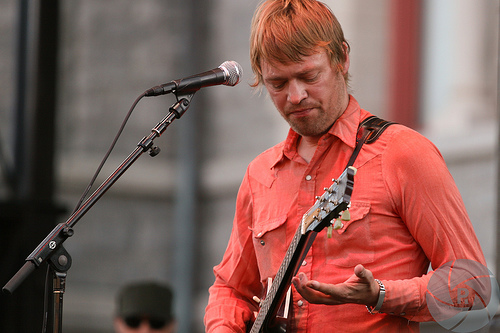<image>
Is the human on the wall? No. The human is not positioned on the wall. They may be near each other, but the human is not supported by or resting on top of the wall. 